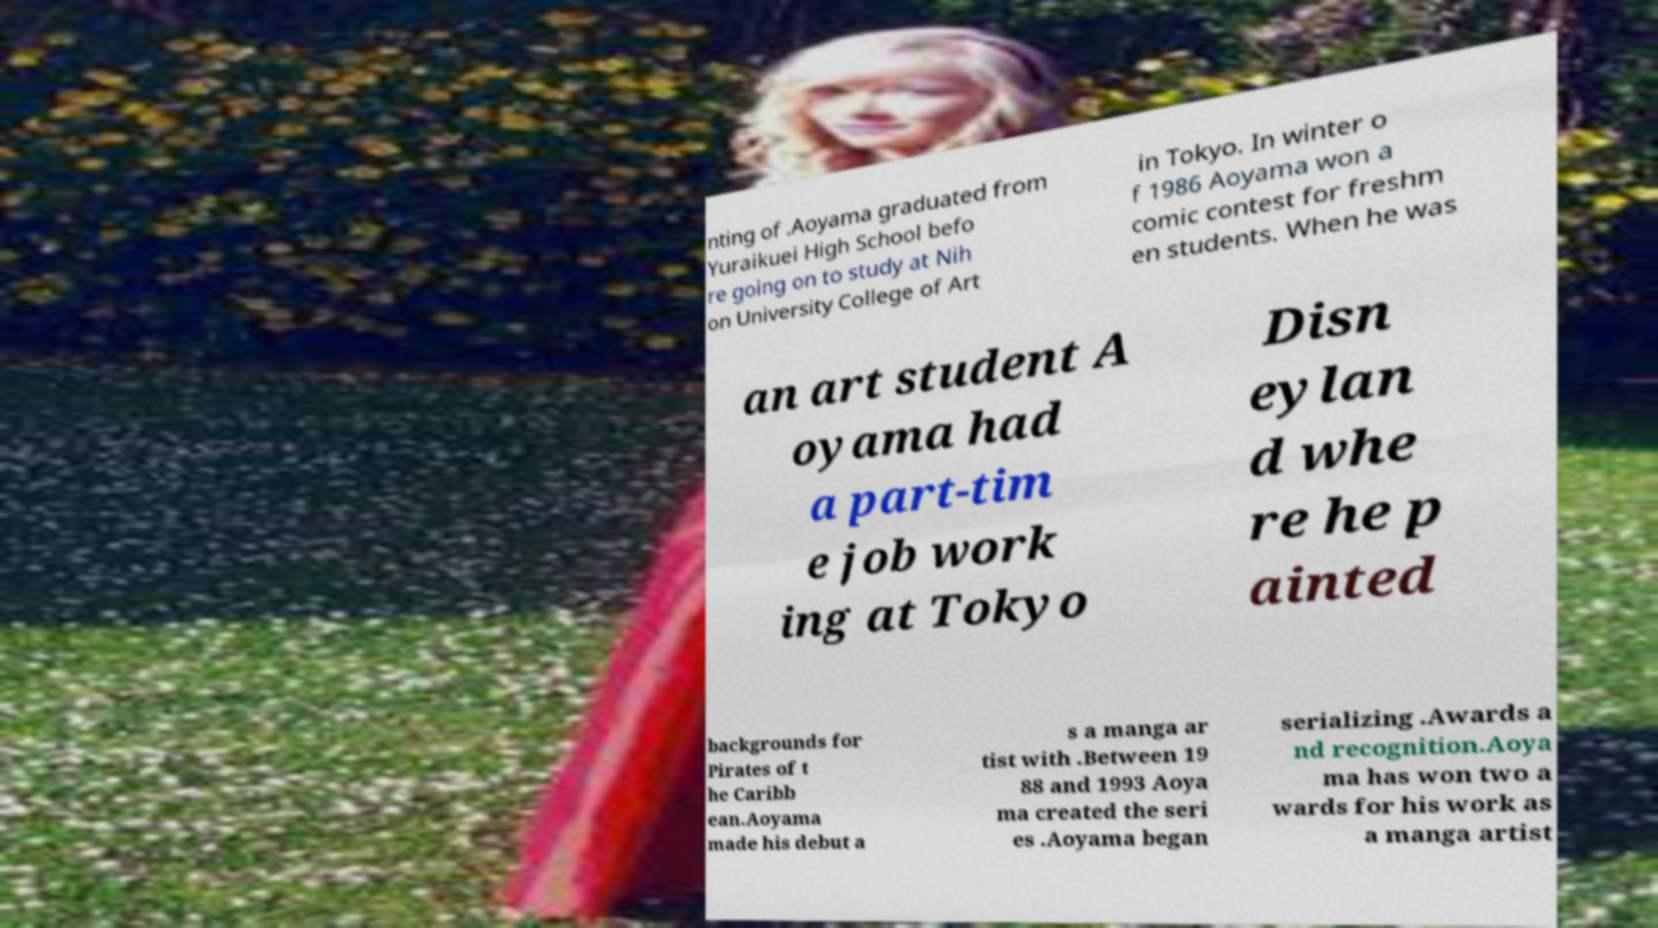Could you extract and type out the text from this image? nting of .Aoyama graduated from Yuraikuei High School befo re going on to study at Nih on University College of Art in Tokyo. In winter o f 1986 Aoyama won a comic contest for freshm en students. When he was an art student A oyama had a part-tim e job work ing at Tokyo Disn eylan d whe re he p ainted backgrounds for Pirates of t he Caribb ean.Aoyama made his debut a s a manga ar tist with .Between 19 88 and 1993 Aoya ma created the seri es .Aoyama began serializing .Awards a nd recognition.Aoya ma has won two a wards for his work as a manga artist 